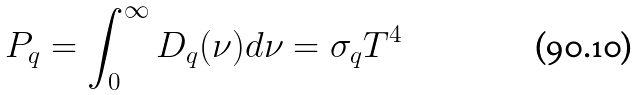<formula> <loc_0><loc_0><loc_500><loc_500>P _ { q } = \int _ { 0 } ^ { \infty } D _ { q } ( \nu ) d \nu = \sigma _ { q } T ^ { 4 }</formula> 